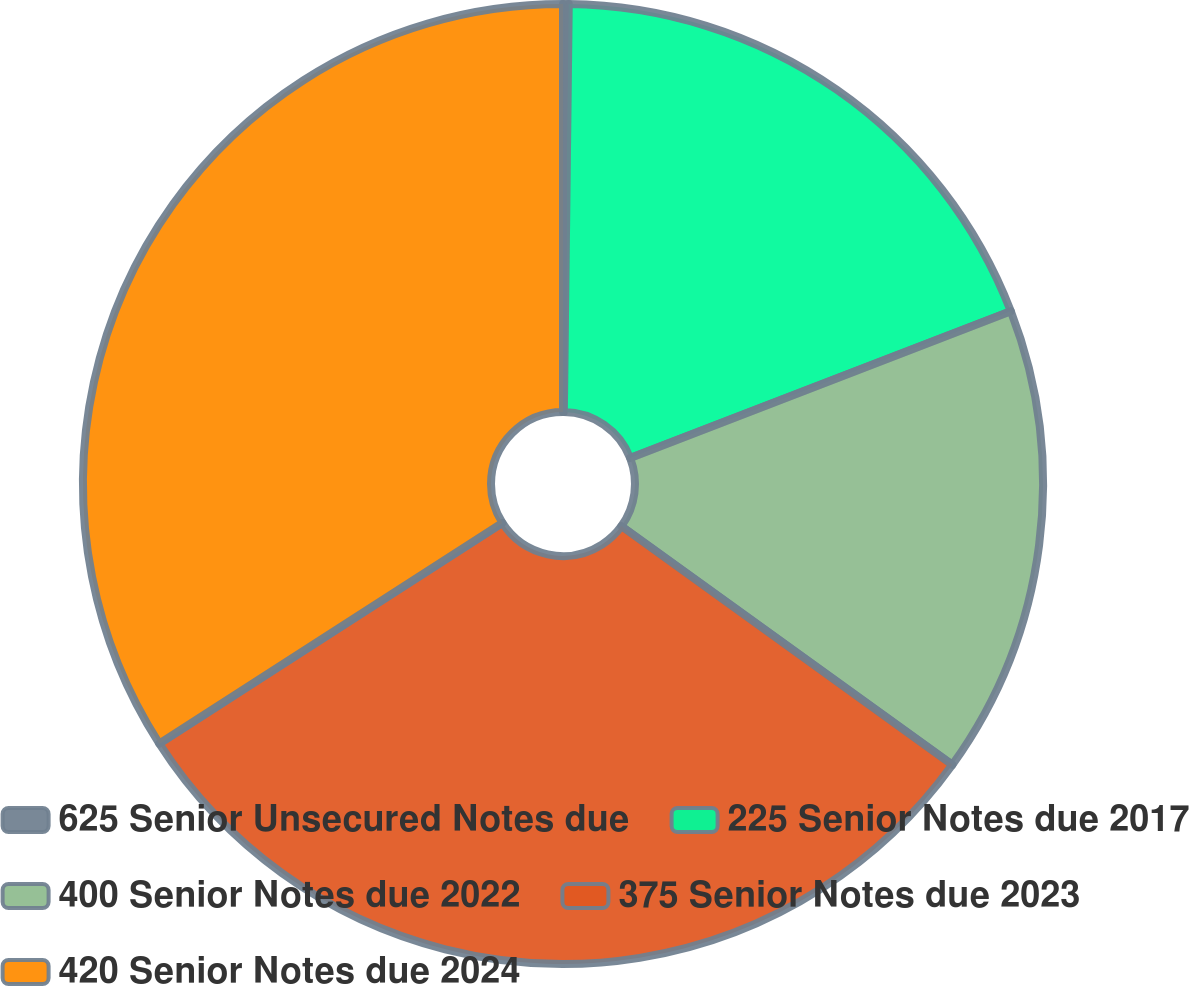Convert chart to OTSL. <chart><loc_0><loc_0><loc_500><loc_500><pie_chart><fcel>625 Senior Unsecured Notes due<fcel>225 Senior Notes due 2017<fcel>400 Senior Notes due 2022<fcel>375 Senior Notes due 2023<fcel>420 Senior Notes due 2024<nl><fcel>0.19%<fcel>18.95%<fcel>15.81%<fcel>30.96%<fcel>34.1%<nl></chart> 